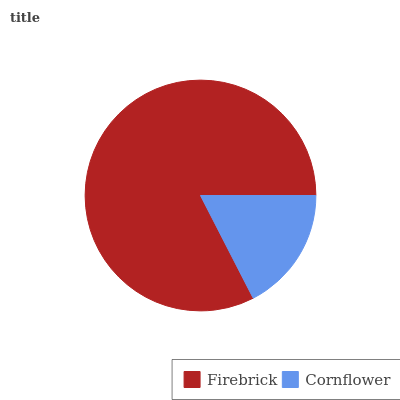Is Cornflower the minimum?
Answer yes or no. Yes. Is Firebrick the maximum?
Answer yes or no. Yes. Is Cornflower the maximum?
Answer yes or no. No. Is Firebrick greater than Cornflower?
Answer yes or no. Yes. Is Cornflower less than Firebrick?
Answer yes or no. Yes. Is Cornflower greater than Firebrick?
Answer yes or no. No. Is Firebrick less than Cornflower?
Answer yes or no. No. Is Firebrick the high median?
Answer yes or no. Yes. Is Cornflower the low median?
Answer yes or no. Yes. Is Cornflower the high median?
Answer yes or no. No. Is Firebrick the low median?
Answer yes or no. No. 